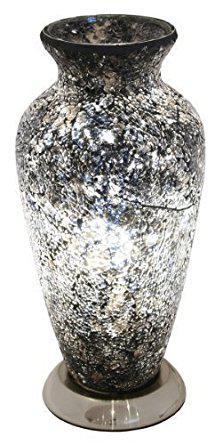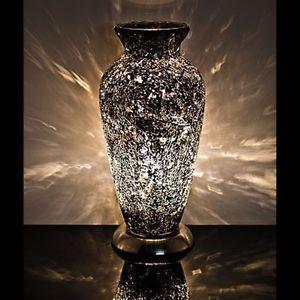The first image is the image on the left, the second image is the image on the right. Considering the images on both sides, is "A vase is displayed against a plain black background." valid? Answer yes or no. No. 